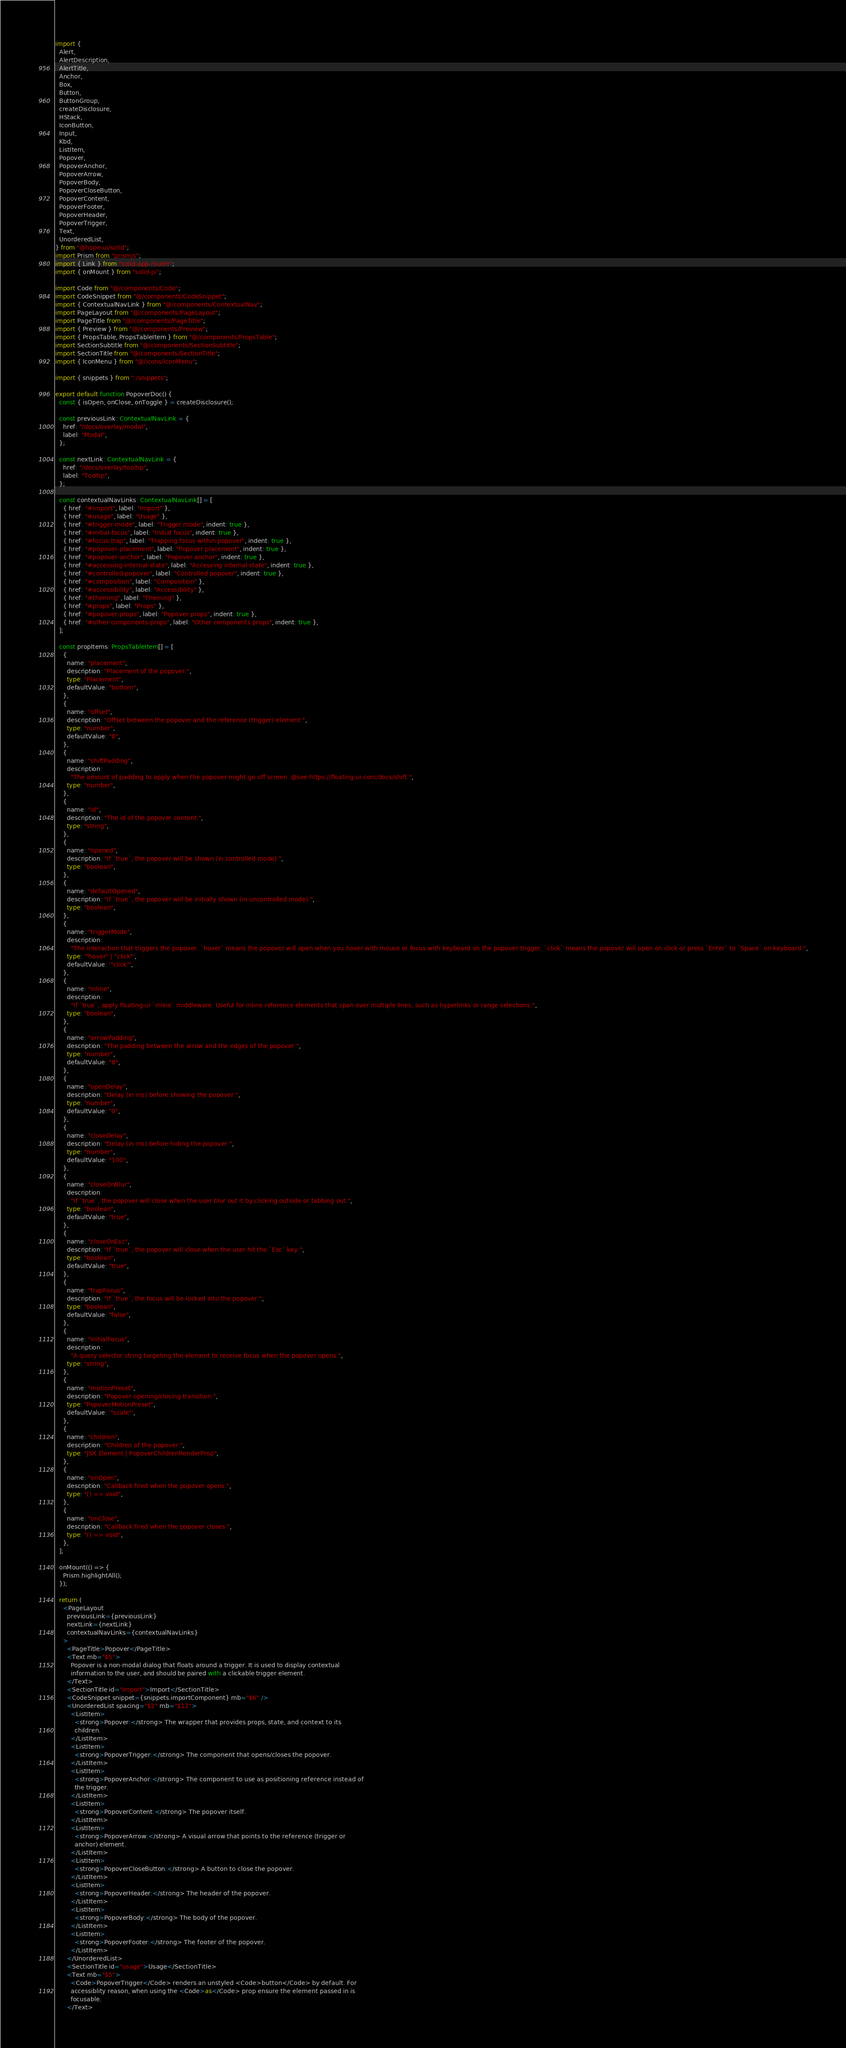Convert code to text. <code><loc_0><loc_0><loc_500><loc_500><_TypeScript_>import {
  Alert,
  AlertDescription,
  AlertTitle,
  Anchor,
  Box,
  Button,
  ButtonGroup,
  createDisclosure,
  HStack,
  IconButton,
  Input,
  Kbd,
  ListItem,
  Popover,
  PopoverAnchor,
  PopoverArrow,
  PopoverBody,
  PopoverCloseButton,
  PopoverContent,
  PopoverFooter,
  PopoverHeader,
  PopoverTrigger,
  Text,
  UnorderedList,
} from "@hope-ui/solid";
import Prism from "prismjs";
import { Link } from "solid-app-router";
import { onMount } from "solid-js";

import Code from "@/components/Code";
import CodeSnippet from "@/components/CodeSnippet";
import { ContextualNavLink } from "@/components/ContextualNav";
import PageLayout from "@/components/PageLayout";
import PageTitle from "@/components/PageTitle";
import { Preview } from "@/components/Preview";
import { PropsTable, PropsTableItem } from "@/components/PropsTable";
import SectionSubtitle from "@/components/SectionSubtitle";
import SectionTitle from "@/components/SectionTitle";
import { IconMenu } from "@/icons/IconMenu";

import { snippets } from "./snippets";

export default function PopoverDoc() {
  const { isOpen, onClose, onToggle } = createDisclosure();

  const previousLink: ContextualNavLink = {
    href: "/docs/overlay/modal",
    label: "Modal",
  };

  const nextLink: ContextualNavLink = {
    href: "/docs/overlay/tooltip",
    label: "Tooltip",
  };

  const contextualNavLinks: ContextualNavLink[] = [
    { href: "#import", label: "Import" },
    { href: "#usage", label: "Usage" },
    { href: "#trigger-mode", label: "Trigger mode", indent: true },
    { href: "#initial-focus", label: "Initial focus", indent: true },
    { href: "#focus-trap", label: "Trapping focus within popover", indent: true },
    { href: "#popover-placement", label: "Popover placement", indent: true },
    { href: "#popover-anchor", label: "Popover anchor", indent: true },
    { href: "#accessing-internal-state", label: "Accessing internal state", indent: true },
    { href: "#controlled-popover", label: "Controlled popover", indent: true },
    { href: "#composition", label: "Composition" },
    { href: "#accessibility", label: "Accessibility" },
    { href: "#theming", label: "Theming" },
    { href: "#props", label: "Props" },
    { href: "#popover-props", label: "Popover props", indent: true },
    { href: "#other-components-props", label: "Other components props", indent: true },
  ];

  const propItems: PropsTableItem[] = [
    {
      name: "placement",
      description: "Placement of the popover.",
      type: "Placement",
      defaultValue: "bottom",
    },
    {
      name: "offset",
      description: "Offset between the popover and the reference (trigger) element.",
      type: "number",
      defaultValue: "8",
    },
    {
      name: "shiftPadding",
      description:
        "The amount of padding to apply when the popover might go off screen. @see https://floating-ui.com/docs/shift.",
      type: "number",
    },
    {
      name: "id",
      description: "The id of the popover content.",
      type: "string",
    },
    {
      name: "opened",
      description: "If `true`, the popover will be shown (in controlled mode).",
      type: "boolean",
    },
    {
      name: "defaultOpened",
      description: "If `true`, the popover will be initially shown (in uncontrolled mode).",
      type: "boolean",
    },
    {
      name: "triggerMode",
      description:
        "The interaction that triggers the popover. `hover` means the popover will open when you hover with mouse or focus with keyboard on the popover trigger. `click` means the popover will open on click or press `Enter` to `Space` on keyboard.",
      type: '"hover" | "click"',
      defaultValue: '"click"',
    },
    {
      name: "inline",
      description:
        "If `true`, apply floating-ui `inline` middleware. Useful for inline reference elements that span over multiple lines, such as hyperlinks or range selections.",
      type: "boolean",
    },
    {
      name: "arrowPadding",
      description: "The padding between the arrow and the edges of the popover.",
      type: "number",
      defaultValue: "8",
    },
    {
      name: "openDelay",
      description: "Delay (in ms) before showing the popover.",
      type: "number",
      defaultValue: "0",
    },
    {
      name: "closeDelay",
      description: "Delay (in ms) before hiding the popover.",
      type: "number",
      defaultValue: "100",
    },
    {
      name: "closeOnBlur",
      description:
        "If `true`, the popover will close when the user blur out it by clicking outside or tabbing out.",
      type: "boolean",
      defaultValue: "true",
    },
    {
      name: "closeOnEsc",
      description: "If `true`, the popover will close when the user hit the `Esc` key.",
      type: "boolean",
      defaultValue: "true",
    },
    {
      name: "trapFocus",
      description: "If `true`, the focus will be locked into the popover.",
      type: "boolean",
      defaultValue: "false",
    },
    {
      name: "initialFocus",
      description:
        "A query selector string targeting the element to receive focus when the popover opens.",
      type: "string",
    },
    {
      name: "motionPreset",
      description: "Popover opening/closing transition.",
      type: "PopoverMotionPreset",
      defaultValue: '"scale"',
    },
    {
      name: "children",
      description: "Children of the popover.",
      type: "JSX.Element | PopoverChildrenRenderProp",
    },
    {
      name: "onOpen",
      description: "Callback fired when the popover opens.",
      type: "() => void",
    },
    {
      name: "onClose",
      description: "Callback fired when the popover closes.",
      type: "() => void",
    },
  ];

  onMount(() => {
    Prism.highlightAll();
  });

  return (
    <PageLayout
      previousLink={previousLink}
      nextLink={nextLink}
      contextualNavLinks={contextualNavLinks}
    >
      <PageTitle>Popover</PageTitle>
      <Text mb="$5">
        Popover is a non-modal dialog that floats around a trigger. It is used to display contextual
        information to the user, and should be paired with a clickable trigger element.
      </Text>
      <SectionTitle id="import">Import</SectionTitle>
      <CodeSnippet snippet={snippets.importComponent} mb="$6" />
      <UnorderedList spacing="$2" mb="$12">
        <ListItem>
          <strong>Popover:</strong> The wrapper that provides props, state, and context to its
          children.
        </ListItem>
        <ListItem>
          <strong>PopoverTrigger:</strong> The component that opens/closes the popover.
        </ListItem>
        <ListItem>
          <strong>PopoverAnchor:</strong> The component to use as positioning reference instead of
          the trigger.
        </ListItem>
        <ListItem>
          <strong>PopoverContent:</strong> The popover itself.
        </ListItem>
        <ListItem>
          <strong>PopoverArrow:</strong> A visual arrow that points to the reference (trigger or
          anchor) element.
        </ListItem>
        <ListItem>
          <strong>PopoverCloseButton:</strong> A button to close the popover.
        </ListItem>
        <ListItem>
          <strong>PopoverHeader:</strong> The header of the popover.
        </ListItem>
        <ListItem>
          <strong>PopoverBody:</strong> The body of the popover.
        </ListItem>
        <ListItem>
          <strong>PopoverFooter:</strong> The footer of the popover.
        </ListItem>
      </UnorderedList>
      <SectionTitle id="usage">Usage</SectionTitle>
      <Text mb="$5">
        <Code>PopoverTrigger</Code> renders an unstyled <Code>button</Code> by default. For
        accessiblity reason, when using the <Code>as</Code> prop ensure the element passed in is
        focusable.
      </Text></code> 